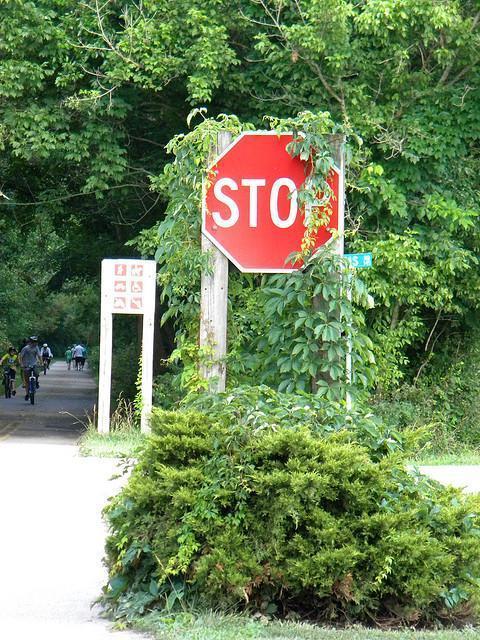How many stop signs are in the picture?
Give a very brief answer. 1. 